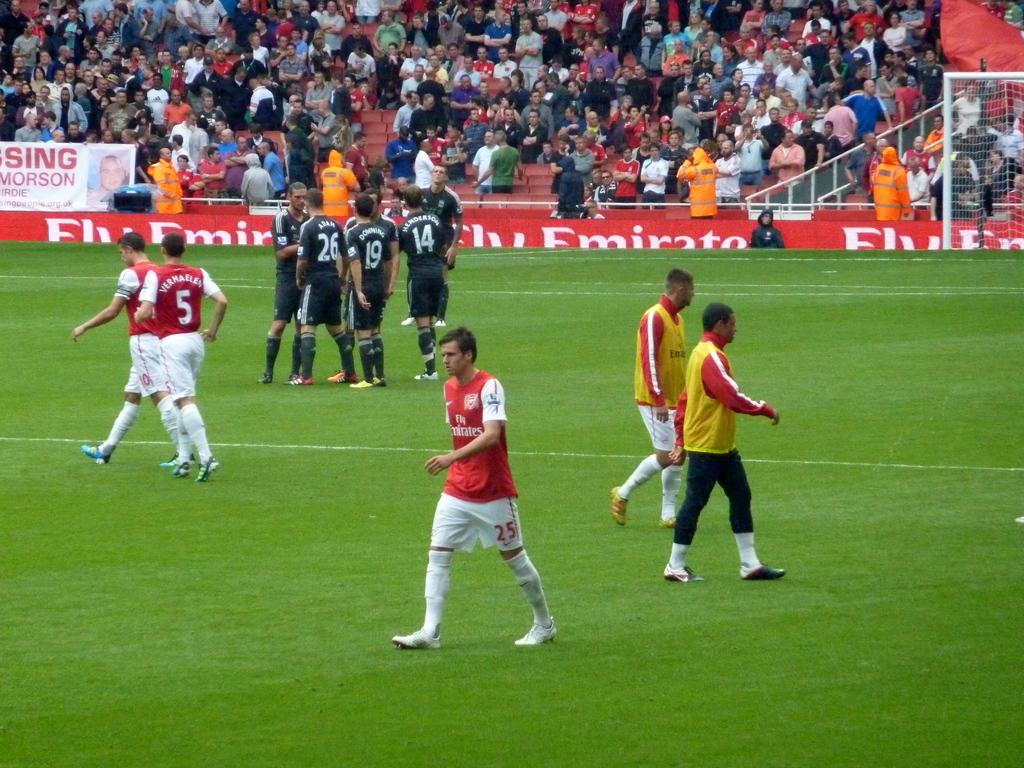Who or what can be seen in the image? There are people in the image. What type of surface is visible in the image? There is grass in the image. What decorative elements are present in the image? There are banners in the image. What material is visible in the image? There is mesh in the image. What other objects can be seen in the image besides the people, grass, banners, and mesh? There are other objects in the image. Can you describe the group of people in the background of the image? There is a group of people in the background of the image. What type of station can be seen in the image? There is no station present in the image. How many boats are visible in the image? There are no boats visible in the image. 